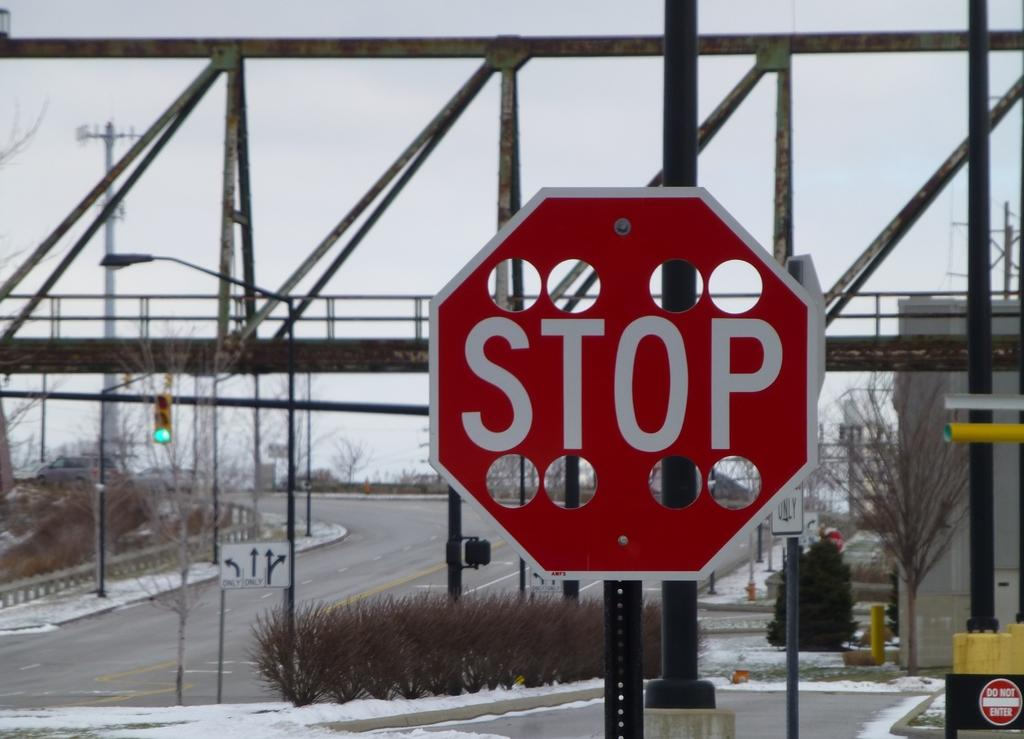Provide a one-sentence caption for the provided image. A stop sign in front of a railroad bridge has 8 large holes carved out on the top and bottom. 